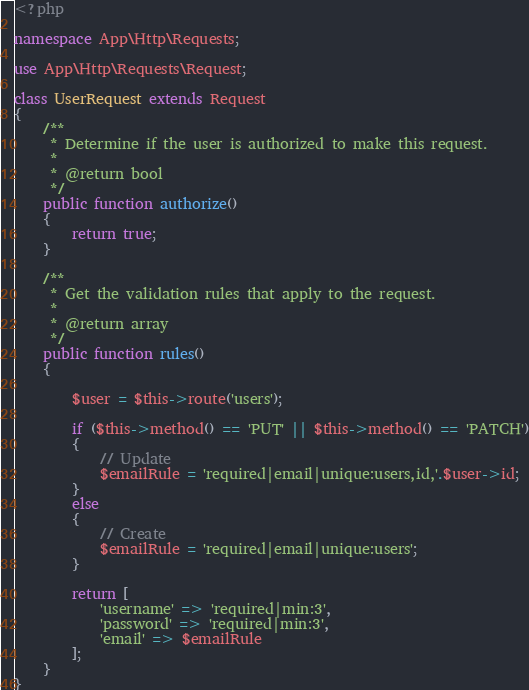<code> <loc_0><loc_0><loc_500><loc_500><_PHP_><?php

namespace App\Http\Requests;

use App\Http\Requests\Request;

class UserRequest extends Request
{
    /**
     * Determine if the user is authorized to make this request.
     *
     * @return bool
     */
    public function authorize()
    {
        return true;
    }

    /**
     * Get the validation rules that apply to the request.
     *
     * @return array
     */
    public function rules()
    {

        $user = $this->route('users');

        if ($this->method() == 'PUT' || $this->method() == 'PATCH')
        {
            // Update
            $emailRule = 'required|email|unique:users,id,'.$user->id;
        }
        else
        {
            // Create
            $emailRule = 'required|email|unique:users';
        }

        return [
            'username' => 'required|min:3',
            'password' => 'required|min:3',
            'email' => $emailRule
        ];
    }
}
</code> 